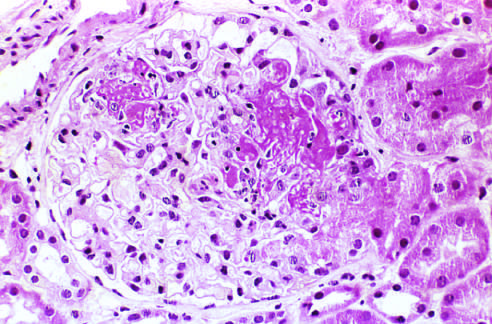s the embolus not prominent in this case?
Answer the question using a single word or phrase. No 